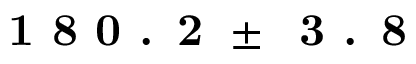Convert formula to latex. <formula><loc_0><loc_0><loc_500><loc_500>1 8 0 . 2 \pm \, 3 . 8</formula> 